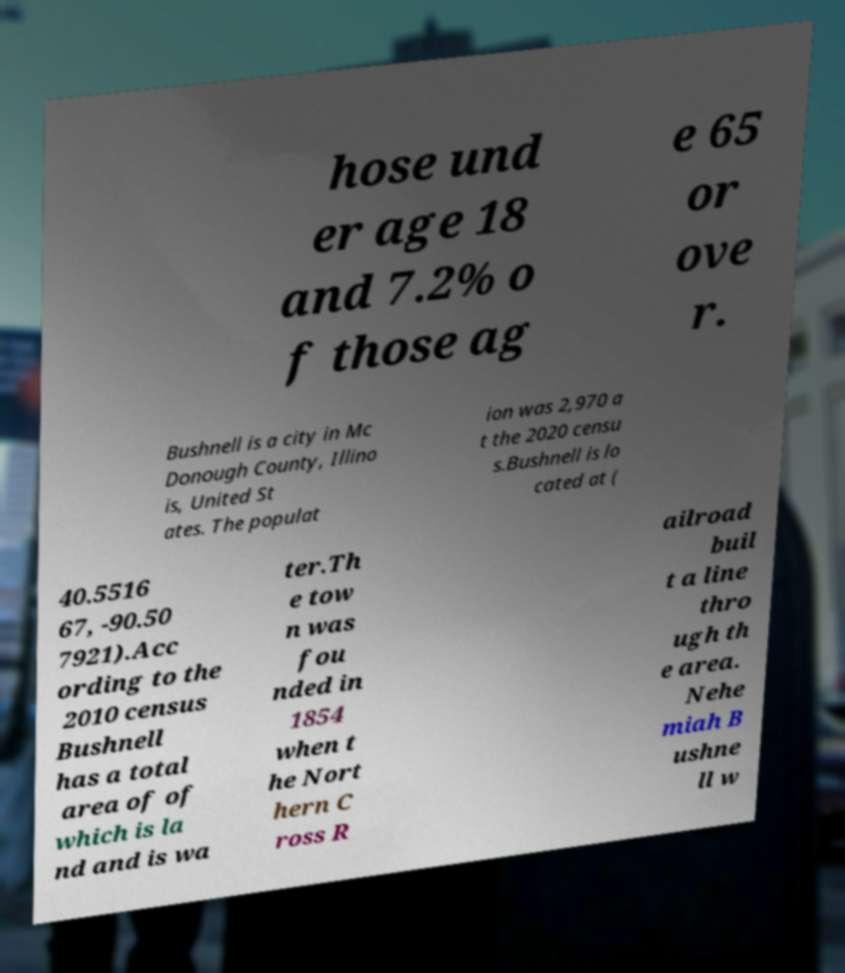For documentation purposes, I need the text within this image transcribed. Could you provide that? hose und er age 18 and 7.2% o f those ag e 65 or ove r. Bushnell is a city in Mc Donough County, Illino is, United St ates. The populat ion was 2,970 a t the 2020 censu s.Bushnell is lo cated at ( 40.5516 67, -90.50 7921).Acc ording to the 2010 census Bushnell has a total area of of which is la nd and is wa ter.Th e tow n was fou nded in 1854 when t he Nort hern C ross R ailroad buil t a line thro ugh th e area. Nehe miah B ushne ll w 